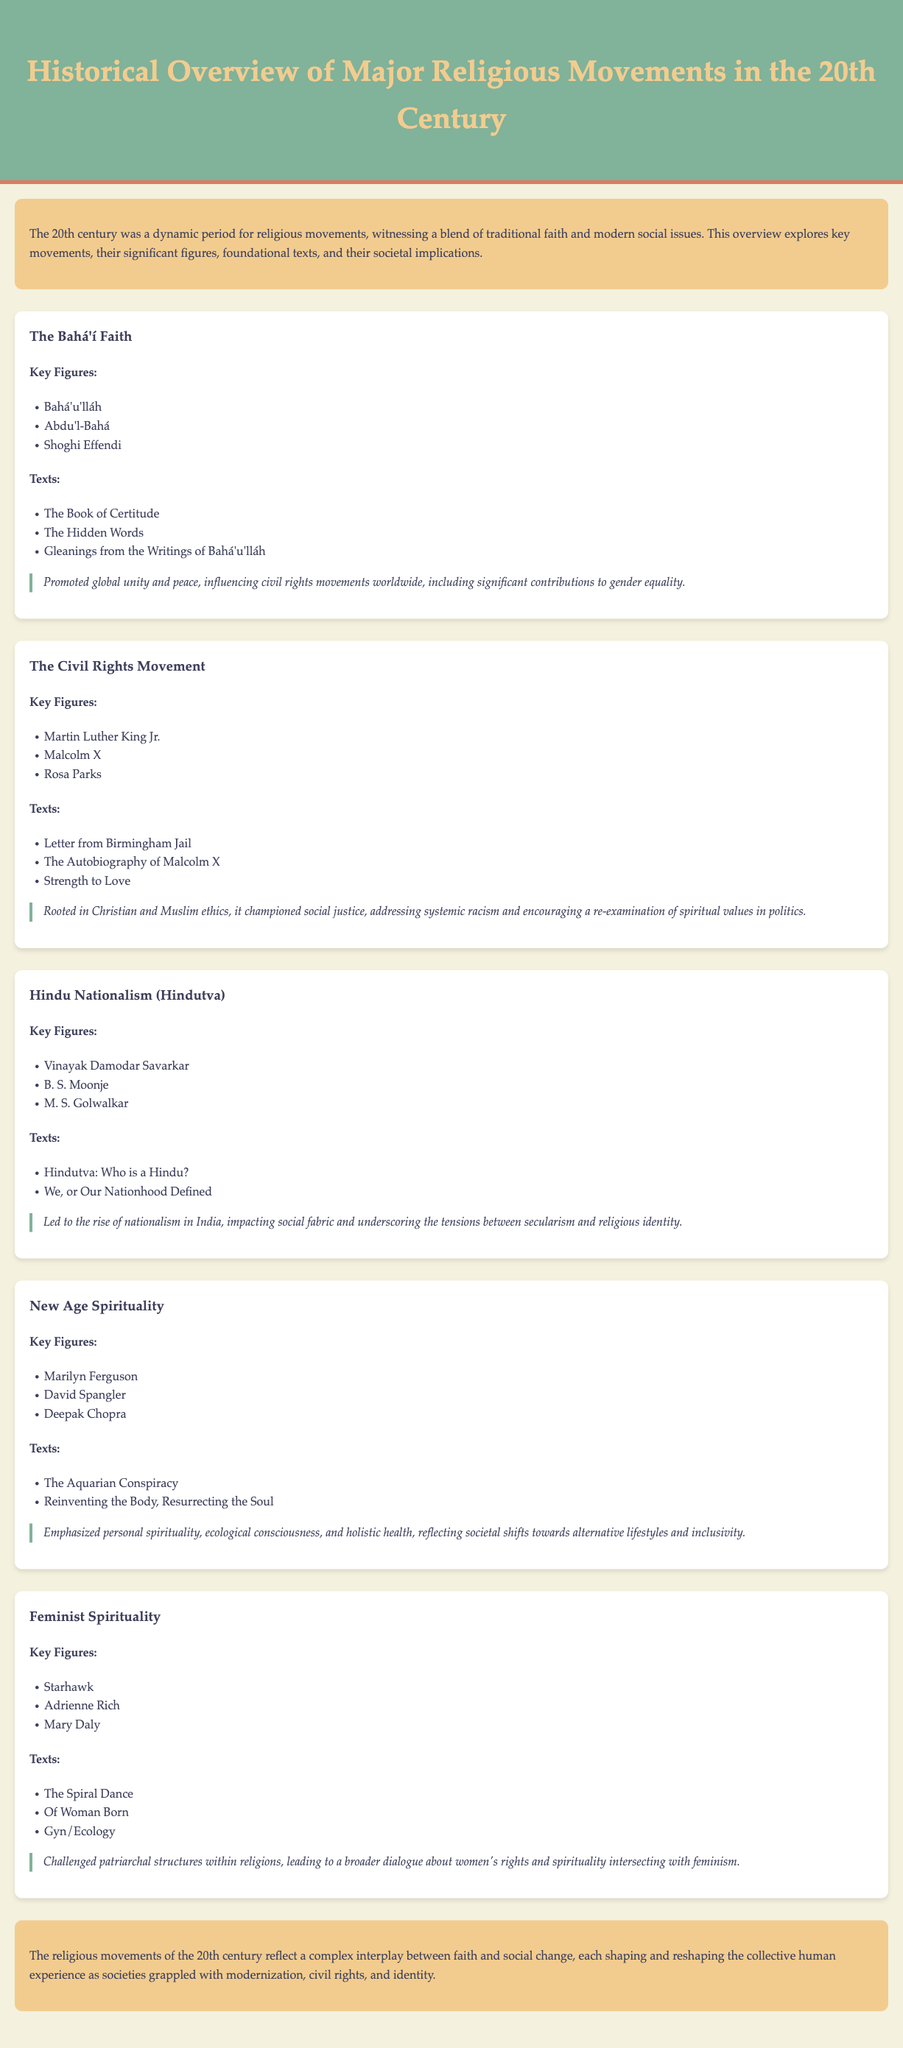What is the title of the document? The title of the document is mentioned at the top of the header section.
Answer: Historical Overview of Major Religious Movements in the 20th Century Who is a key figure in the Bahá'í Faith? The document lists key figures for the Bahá'í Faith in a specific section.
Answer: Bahá'u'lláh What is one foundational text of the Civil Rights Movement? The document includes a list of texts associated with the Civil Rights Movement.
Answer: Letter from Birmingham Jail What social implication is associated with Hindu Nationalism (Hindutva)? The document describes the social implications related to each movement, including Hindu Nationalism.
Answer: Rise of nationalism in India How many key figures are listed for New Age Spirituality? The number of key figures is included in the section about New Age Spirituality.
Answer: Three What is a common theme in the social implications of the movements? Examining the entire document, multiple movements address social issues related to rights and identity.
Answer: Social justice Who wrote "The Spiral Dance"? The document lists key figures along with their influential works, including this title.
Answer: Starhawk What color is used for the header background? The design choices, such as color, are specified at the beginning of the document.
Answer: #81b29a 